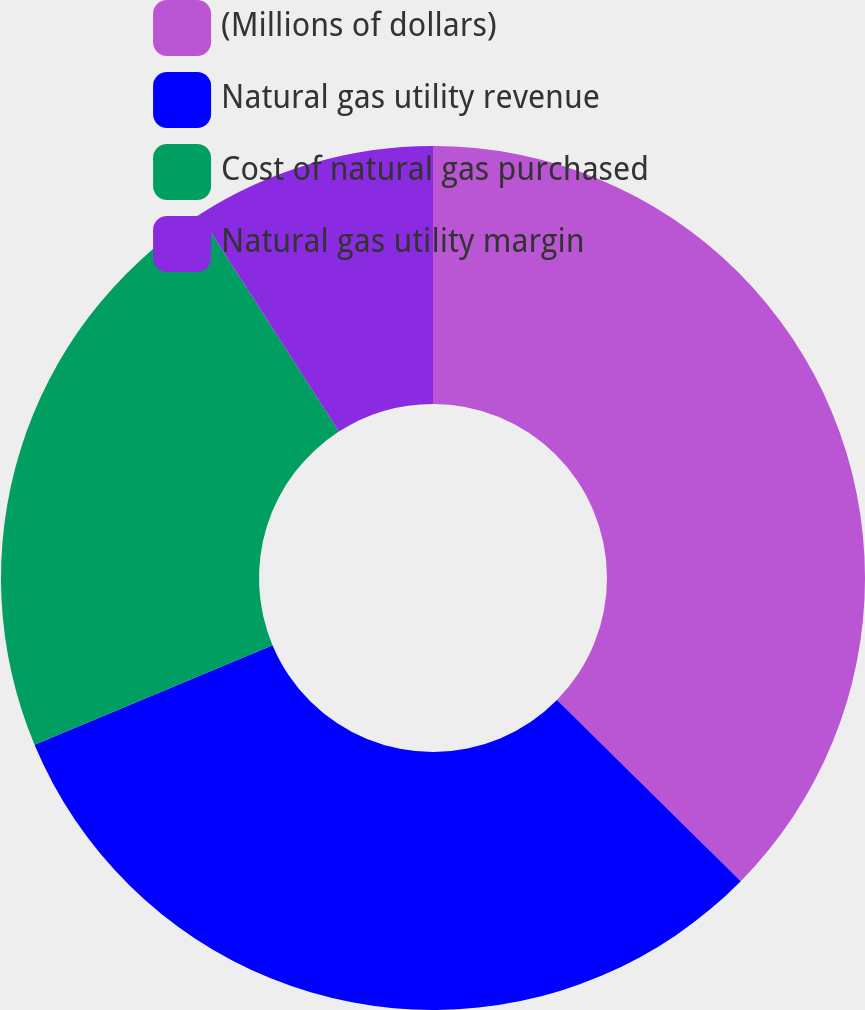<chart> <loc_0><loc_0><loc_500><loc_500><pie_chart><fcel>(Millions of dollars)<fcel>Natural gas utility revenue<fcel>Cost of natural gas purchased<fcel>Natural gas utility margin<nl><fcel>37.38%<fcel>31.31%<fcel>22.22%<fcel>9.09%<nl></chart> 